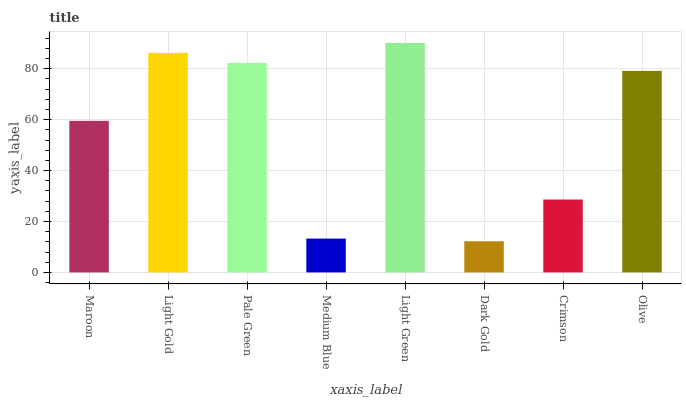Is Light Gold the minimum?
Answer yes or no. No. Is Light Gold the maximum?
Answer yes or no. No. Is Light Gold greater than Maroon?
Answer yes or no. Yes. Is Maroon less than Light Gold?
Answer yes or no. Yes. Is Maroon greater than Light Gold?
Answer yes or no. No. Is Light Gold less than Maroon?
Answer yes or no. No. Is Olive the high median?
Answer yes or no. Yes. Is Maroon the low median?
Answer yes or no. Yes. Is Light Gold the high median?
Answer yes or no. No. Is Crimson the low median?
Answer yes or no. No. 